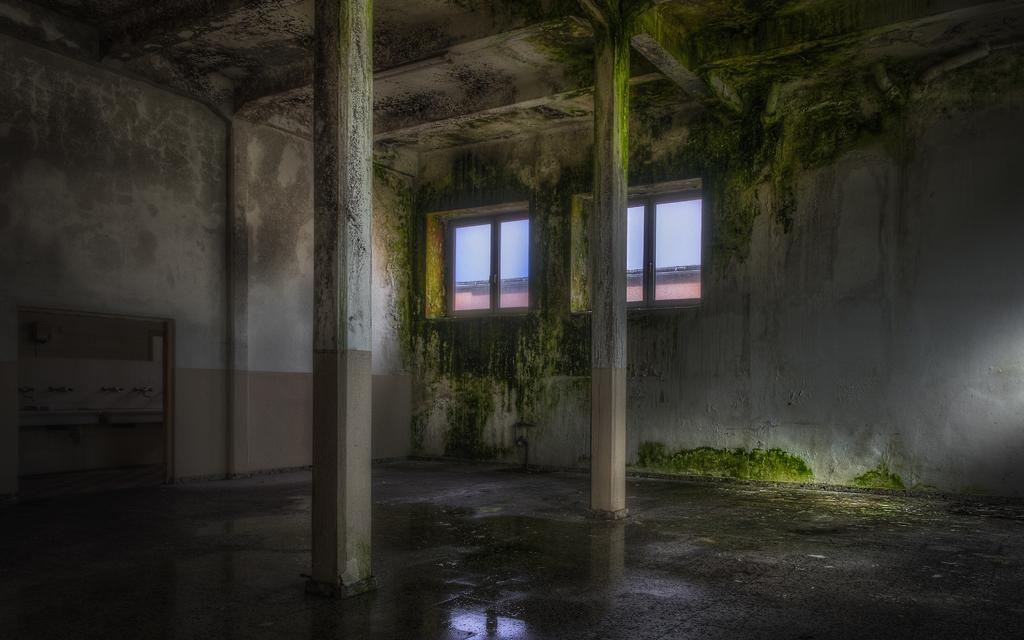What type of location is depicted in the image? The image shows an inside view of a room. What specific feature can be seen in the room? There are taps visible in the room. What type of club is being used in the image? There is no club present in the image. What letters can be seen on the taps in the image? The image does not show any letters on the taps. 